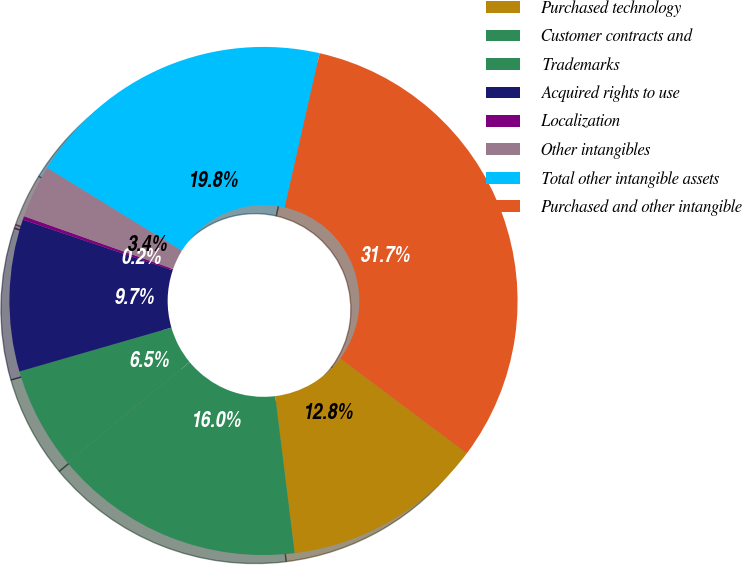<chart> <loc_0><loc_0><loc_500><loc_500><pie_chart><fcel>Purchased technology<fcel>Customer contracts and<fcel>Trademarks<fcel>Acquired rights to use<fcel>Localization<fcel>Other intangibles<fcel>Total other intangible assets<fcel>Purchased and other intangible<nl><fcel>12.81%<fcel>15.96%<fcel>6.52%<fcel>9.66%<fcel>0.23%<fcel>3.37%<fcel>19.76%<fcel>31.68%<nl></chart> 